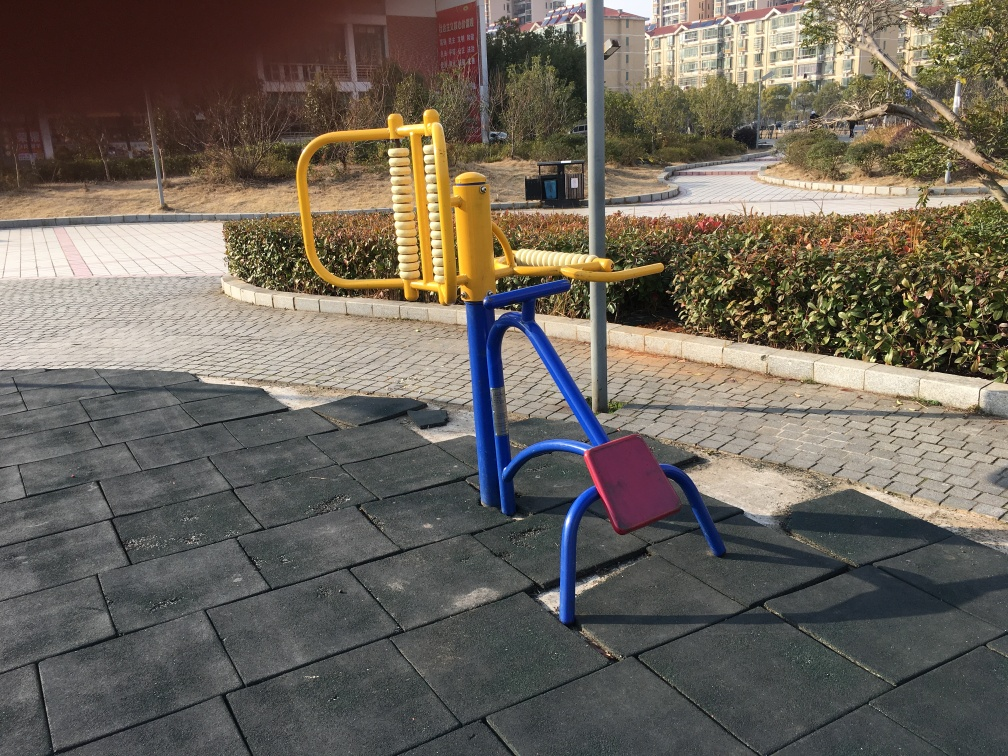What kind of setting does this image portray? The image depicts an outdoor fitness area, likely situated within a public park given the presence of bushes, paved pathways, and an open space indicative of a recreational environment. 